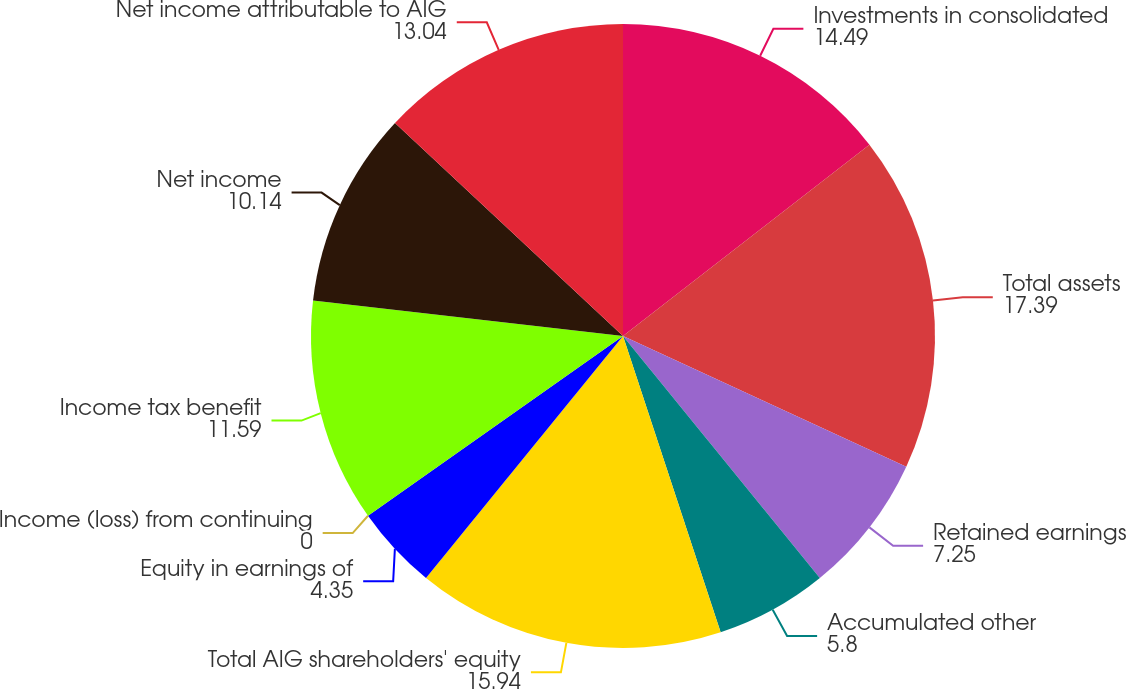<chart> <loc_0><loc_0><loc_500><loc_500><pie_chart><fcel>Investments in consolidated<fcel>Total assets<fcel>Retained earnings<fcel>Accumulated other<fcel>Total AIG shareholders' equity<fcel>Equity in earnings of<fcel>Income (loss) from continuing<fcel>Income tax benefit<fcel>Net income<fcel>Net income attributable to AIG<nl><fcel>14.49%<fcel>17.39%<fcel>7.25%<fcel>5.8%<fcel>15.94%<fcel>4.35%<fcel>0.0%<fcel>11.59%<fcel>10.14%<fcel>13.04%<nl></chart> 